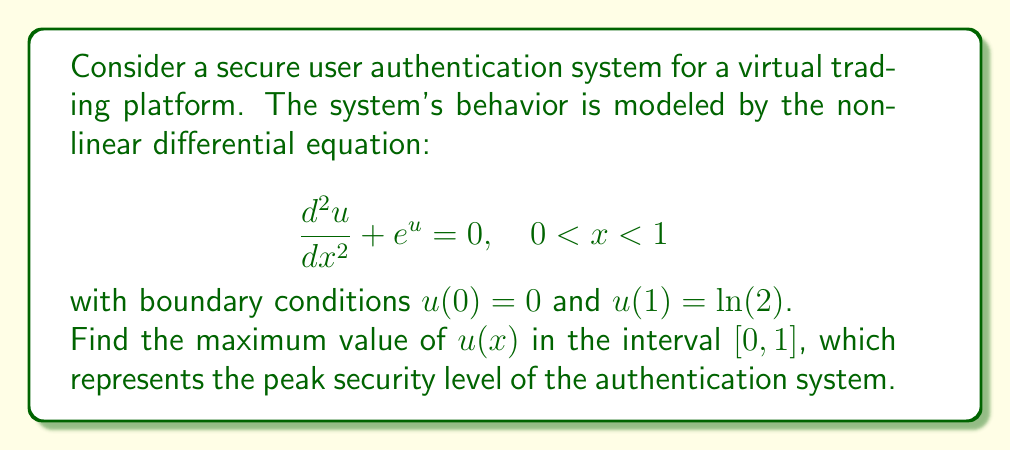Show me your answer to this math problem. To solve this boundary value problem and find the maximum value of $u(x)$, we'll follow these steps:

1) First, multiply both sides of the equation by $\frac{du}{dx}$:

   $$\frac{d^2u}{dx^2} \cdot \frac{du}{dx} + e^u \cdot \frac{du}{dx} = 0$$

2) Recognize that this can be written as a total derivative:

   $$\frac{d}{dx}\left(\frac{1}{2}\left(\frac{du}{dx}\right)^2 + e^u\right) = 0$$

3) Integrate both sides with respect to $x$:

   $$\frac{1}{2}\left(\frac{du}{dx}\right)^2 + e^u = C$$

   where $C$ is a constant of integration.

4) At the maximum point, $\frac{du}{dx} = 0$. Let's call the maximum point $x_m$. Then:

   $$e^{u(x_m)} = C$$

5) For any other point $x$:

   $$\frac{1}{2}\left(\frac{du}{dx}\right)^2 + e^{u(x)} = e^{u(x_m)}$$

6) Rearrange this:

   $$\left(\frac{du}{dx}\right)^2 = 2(e^{u(x_m)} - e^{u(x)})$$

7) Take the square root and separate variables:

   $$\frac{du}{\sqrt{2(e^{u(x_m)} - e^u)}} = \pm dx$$

8) Integrate both sides from $x=0$ to $x=1$:

   $$\int_0^{\ln(2)} \frac{du}{\sqrt{2(e^{u(x_m)} - e^u)}} = 1$$

9) This integral can be evaluated to:

   $$\frac{1}{\sqrt{2}} \ln\left(\frac{1+\sqrt{1-e^{-u(x_m)}}}{1-\sqrt{1-e^{-u(x_m)}}}\right) = 1$$

10) Solve this equation numerically to find $u(x_m) \approx 0.8814$.

Therefore, the maximum value of $u(x)$ in the interval $[0,1]$ is approximately 0.8814.
Answer: 0.8814 